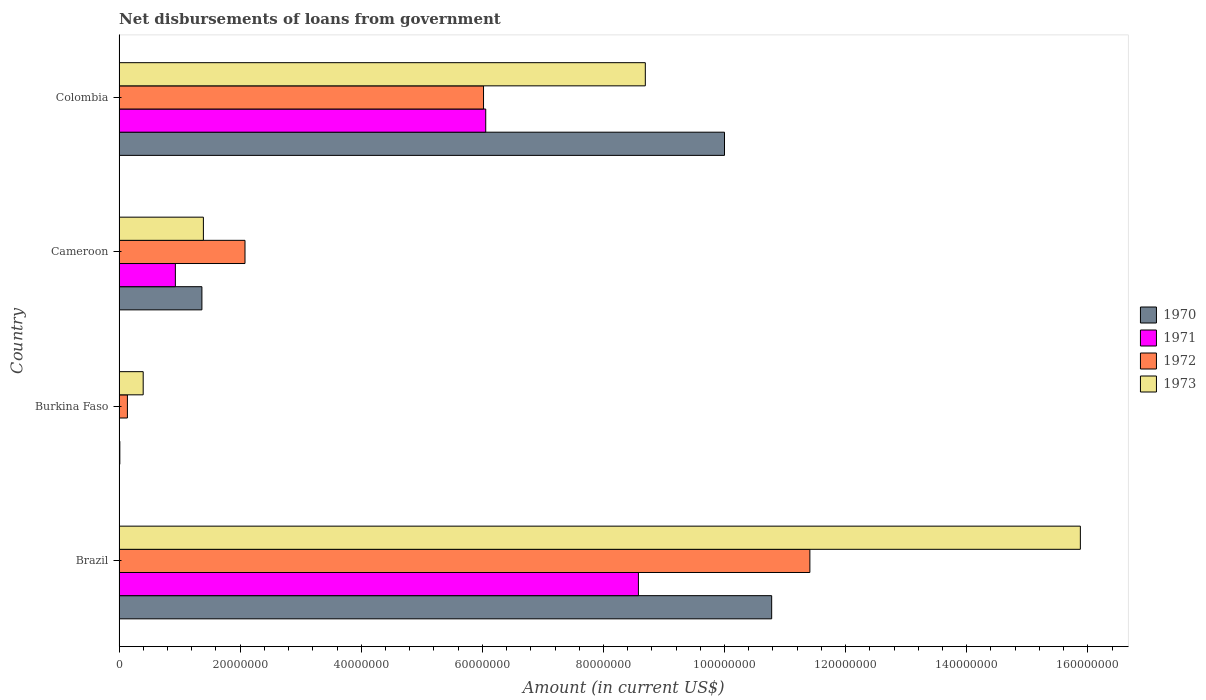How many different coloured bars are there?
Make the answer very short. 4. How many groups of bars are there?
Give a very brief answer. 4. Are the number of bars on each tick of the Y-axis equal?
Provide a succinct answer. No. How many bars are there on the 3rd tick from the top?
Offer a very short reply. 3. How many bars are there on the 4th tick from the bottom?
Your response must be concise. 4. What is the label of the 3rd group of bars from the top?
Your answer should be very brief. Burkina Faso. In how many cases, is the number of bars for a given country not equal to the number of legend labels?
Provide a succinct answer. 1. What is the amount of loan disbursed from government in 1973 in Colombia?
Keep it short and to the point. 8.69e+07. Across all countries, what is the maximum amount of loan disbursed from government in 1970?
Your answer should be very brief. 1.08e+08. Across all countries, what is the minimum amount of loan disbursed from government in 1972?
Give a very brief answer. 1.38e+06. What is the total amount of loan disbursed from government in 1971 in the graph?
Ensure brevity in your answer.  1.56e+08. What is the difference between the amount of loan disbursed from government in 1972 in Burkina Faso and that in Cameroon?
Keep it short and to the point. -1.94e+07. What is the difference between the amount of loan disbursed from government in 1972 in Burkina Faso and the amount of loan disbursed from government in 1971 in Cameroon?
Keep it short and to the point. -7.92e+06. What is the average amount of loan disbursed from government in 1973 per country?
Provide a short and direct response. 6.59e+07. What is the difference between the amount of loan disbursed from government in 1970 and amount of loan disbursed from government in 1972 in Brazil?
Keep it short and to the point. -6.31e+06. What is the ratio of the amount of loan disbursed from government in 1970 in Burkina Faso to that in Colombia?
Offer a terse response. 0. Is the amount of loan disbursed from government in 1972 in Brazil less than that in Burkina Faso?
Provide a succinct answer. No. Is the difference between the amount of loan disbursed from government in 1970 in Burkina Faso and Cameroon greater than the difference between the amount of loan disbursed from government in 1972 in Burkina Faso and Cameroon?
Provide a succinct answer. Yes. What is the difference between the highest and the second highest amount of loan disbursed from government in 1971?
Your response must be concise. 2.52e+07. What is the difference between the highest and the lowest amount of loan disbursed from government in 1973?
Ensure brevity in your answer.  1.55e+08. Is the sum of the amount of loan disbursed from government in 1972 in Cameroon and Colombia greater than the maximum amount of loan disbursed from government in 1971 across all countries?
Give a very brief answer. No. Is it the case that in every country, the sum of the amount of loan disbursed from government in 1971 and amount of loan disbursed from government in 1970 is greater than the amount of loan disbursed from government in 1972?
Offer a very short reply. No. Does the graph contain any zero values?
Your response must be concise. Yes. Does the graph contain grids?
Offer a terse response. No. Where does the legend appear in the graph?
Provide a short and direct response. Center right. How many legend labels are there?
Offer a very short reply. 4. How are the legend labels stacked?
Make the answer very short. Vertical. What is the title of the graph?
Provide a succinct answer. Net disbursements of loans from government. What is the label or title of the Y-axis?
Make the answer very short. Country. What is the Amount (in current US$) of 1970 in Brazil?
Keep it short and to the point. 1.08e+08. What is the Amount (in current US$) in 1971 in Brazil?
Give a very brief answer. 8.58e+07. What is the Amount (in current US$) in 1972 in Brazil?
Offer a terse response. 1.14e+08. What is the Amount (in current US$) in 1973 in Brazil?
Make the answer very short. 1.59e+08. What is the Amount (in current US$) in 1970 in Burkina Faso?
Offer a terse response. 1.29e+05. What is the Amount (in current US$) in 1971 in Burkina Faso?
Keep it short and to the point. 0. What is the Amount (in current US$) in 1972 in Burkina Faso?
Your answer should be very brief. 1.38e+06. What is the Amount (in current US$) of 1973 in Burkina Faso?
Ensure brevity in your answer.  3.98e+06. What is the Amount (in current US$) in 1970 in Cameroon?
Your answer should be compact. 1.37e+07. What is the Amount (in current US$) of 1971 in Cameroon?
Offer a terse response. 9.30e+06. What is the Amount (in current US$) of 1972 in Cameroon?
Offer a terse response. 2.08e+07. What is the Amount (in current US$) in 1973 in Cameroon?
Keep it short and to the point. 1.39e+07. What is the Amount (in current US$) in 1970 in Colombia?
Ensure brevity in your answer.  1.00e+08. What is the Amount (in current US$) in 1971 in Colombia?
Offer a very short reply. 6.06e+07. What is the Amount (in current US$) of 1972 in Colombia?
Your answer should be compact. 6.02e+07. What is the Amount (in current US$) in 1973 in Colombia?
Keep it short and to the point. 8.69e+07. Across all countries, what is the maximum Amount (in current US$) of 1970?
Your answer should be compact. 1.08e+08. Across all countries, what is the maximum Amount (in current US$) of 1971?
Give a very brief answer. 8.58e+07. Across all countries, what is the maximum Amount (in current US$) of 1972?
Keep it short and to the point. 1.14e+08. Across all countries, what is the maximum Amount (in current US$) in 1973?
Your response must be concise. 1.59e+08. Across all countries, what is the minimum Amount (in current US$) of 1970?
Offer a very short reply. 1.29e+05. Across all countries, what is the minimum Amount (in current US$) in 1972?
Keep it short and to the point. 1.38e+06. Across all countries, what is the minimum Amount (in current US$) in 1973?
Provide a short and direct response. 3.98e+06. What is the total Amount (in current US$) of 1970 in the graph?
Offer a very short reply. 2.22e+08. What is the total Amount (in current US$) in 1971 in the graph?
Provide a short and direct response. 1.56e+08. What is the total Amount (in current US$) in 1972 in the graph?
Keep it short and to the point. 1.96e+08. What is the total Amount (in current US$) of 1973 in the graph?
Offer a terse response. 2.64e+08. What is the difference between the Amount (in current US$) of 1970 in Brazil and that in Burkina Faso?
Your answer should be very brief. 1.08e+08. What is the difference between the Amount (in current US$) of 1972 in Brazil and that in Burkina Faso?
Make the answer very short. 1.13e+08. What is the difference between the Amount (in current US$) of 1973 in Brazil and that in Burkina Faso?
Provide a short and direct response. 1.55e+08. What is the difference between the Amount (in current US$) of 1970 in Brazil and that in Cameroon?
Provide a short and direct response. 9.41e+07. What is the difference between the Amount (in current US$) in 1971 in Brazil and that in Cameroon?
Keep it short and to the point. 7.65e+07. What is the difference between the Amount (in current US$) in 1972 in Brazil and that in Cameroon?
Provide a succinct answer. 9.33e+07. What is the difference between the Amount (in current US$) of 1973 in Brazil and that in Cameroon?
Offer a terse response. 1.45e+08. What is the difference between the Amount (in current US$) in 1970 in Brazil and that in Colombia?
Your answer should be compact. 7.79e+06. What is the difference between the Amount (in current US$) in 1971 in Brazil and that in Colombia?
Keep it short and to the point. 2.52e+07. What is the difference between the Amount (in current US$) in 1972 in Brazil and that in Colombia?
Offer a very short reply. 5.39e+07. What is the difference between the Amount (in current US$) of 1973 in Brazil and that in Colombia?
Offer a very short reply. 7.19e+07. What is the difference between the Amount (in current US$) in 1970 in Burkina Faso and that in Cameroon?
Offer a terse response. -1.36e+07. What is the difference between the Amount (in current US$) in 1972 in Burkina Faso and that in Cameroon?
Your response must be concise. -1.94e+07. What is the difference between the Amount (in current US$) in 1973 in Burkina Faso and that in Cameroon?
Provide a succinct answer. -9.94e+06. What is the difference between the Amount (in current US$) in 1970 in Burkina Faso and that in Colombia?
Your answer should be very brief. -9.99e+07. What is the difference between the Amount (in current US$) in 1972 in Burkina Faso and that in Colombia?
Ensure brevity in your answer.  -5.88e+07. What is the difference between the Amount (in current US$) in 1973 in Burkina Faso and that in Colombia?
Your response must be concise. -8.29e+07. What is the difference between the Amount (in current US$) of 1970 in Cameroon and that in Colombia?
Offer a terse response. -8.63e+07. What is the difference between the Amount (in current US$) in 1971 in Cameroon and that in Colombia?
Offer a terse response. -5.13e+07. What is the difference between the Amount (in current US$) in 1972 in Cameroon and that in Colombia?
Your answer should be very brief. -3.94e+07. What is the difference between the Amount (in current US$) in 1973 in Cameroon and that in Colombia?
Provide a succinct answer. -7.30e+07. What is the difference between the Amount (in current US$) of 1970 in Brazil and the Amount (in current US$) of 1972 in Burkina Faso?
Your answer should be very brief. 1.06e+08. What is the difference between the Amount (in current US$) of 1970 in Brazil and the Amount (in current US$) of 1973 in Burkina Faso?
Offer a very short reply. 1.04e+08. What is the difference between the Amount (in current US$) in 1971 in Brazil and the Amount (in current US$) in 1972 in Burkina Faso?
Give a very brief answer. 8.44e+07. What is the difference between the Amount (in current US$) in 1971 in Brazil and the Amount (in current US$) in 1973 in Burkina Faso?
Offer a very short reply. 8.18e+07. What is the difference between the Amount (in current US$) of 1972 in Brazil and the Amount (in current US$) of 1973 in Burkina Faso?
Make the answer very short. 1.10e+08. What is the difference between the Amount (in current US$) of 1970 in Brazil and the Amount (in current US$) of 1971 in Cameroon?
Offer a very short reply. 9.85e+07. What is the difference between the Amount (in current US$) in 1970 in Brazil and the Amount (in current US$) in 1972 in Cameroon?
Your response must be concise. 8.70e+07. What is the difference between the Amount (in current US$) of 1970 in Brazil and the Amount (in current US$) of 1973 in Cameroon?
Provide a succinct answer. 9.39e+07. What is the difference between the Amount (in current US$) of 1971 in Brazil and the Amount (in current US$) of 1972 in Cameroon?
Your response must be concise. 6.50e+07. What is the difference between the Amount (in current US$) in 1971 in Brazil and the Amount (in current US$) in 1973 in Cameroon?
Your answer should be compact. 7.18e+07. What is the difference between the Amount (in current US$) of 1972 in Brazil and the Amount (in current US$) of 1973 in Cameroon?
Provide a succinct answer. 1.00e+08. What is the difference between the Amount (in current US$) in 1970 in Brazil and the Amount (in current US$) in 1971 in Colombia?
Keep it short and to the point. 4.72e+07. What is the difference between the Amount (in current US$) of 1970 in Brazil and the Amount (in current US$) of 1972 in Colombia?
Make the answer very short. 4.76e+07. What is the difference between the Amount (in current US$) in 1970 in Brazil and the Amount (in current US$) in 1973 in Colombia?
Your answer should be very brief. 2.09e+07. What is the difference between the Amount (in current US$) of 1971 in Brazil and the Amount (in current US$) of 1972 in Colombia?
Your answer should be very brief. 2.56e+07. What is the difference between the Amount (in current US$) of 1971 in Brazil and the Amount (in current US$) of 1973 in Colombia?
Give a very brief answer. -1.14e+06. What is the difference between the Amount (in current US$) of 1972 in Brazil and the Amount (in current US$) of 1973 in Colombia?
Offer a very short reply. 2.72e+07. What is the difference between the Amount (in current US$) of 1970 in Burkina Faso and the Amount (in current US$) of 1971 in Cameroon?
Provide a short and direct response. -9.17e+06. What is the difference between the Amount (in current US$) in 1970 in Burkina Faso and the Amount (in current US$) in 1972 in Cameroon?
Keep it short and to the point. -2.07e+07. What is the difference between the Amount (in current US$) of 1970 in Burkina Faso and the Amount (in current US$) of 1973 in Cameroon?
Make the answer very short. -1.38e+07. What is the difference between the Amount (in current US$) in 1972 in Burkina Faso and the Amount (in current US$) in 1973 in Cameroon?
Provide a short and direct response. -1.25e+07. What is the difference between the Amount (in current US$) in 1970 in Burkina Faso and the Amount (in current US$) in 1971 in Colombia?
Keep it short and to the point. -6.04e+07. What is the difference between the Amount (in current US$) of 1970 in Burkina Faso and the Amount (in current US$) of 1972 in Colombia?
Offer a terse response. -6.01e+07. What is the difference between the Amount (in current US$) in 1970 in Burkina Faso and the Amount (in current US$) in 1973 in Colombia?
Make the answer very short. -8.68e+07. What is the difference between the Amount (in current US$) in 1972 in Burkina Faso and the Amount (in current US$) in 1973 in Colombia?
Your answer should be compact. -8.55e+07. What is the difference between the Amount (in current US$) of 1970 in Cameroon and the Amount (in current US$) of 1971 in Colombia?
Provide a succinct answer. -4.69e+07. What is the difference between the Amount (in current US$) in 1970 in Cameroon and the Amount (in current US$) in 1972 in Colombia?
Offer a terse response. -4.65e+07. What is the difference between the Amount (in current US$) of 1970 in Cameroon and the Amount (in current US$) of 1973 in Colombia?
Your answer should be very brief. -7.32e+07. What is the difference between the Amount (in current US$) of 1971 in Cameroon and the Amount (in current US$) of 1972 in Colombia?
Your response must be concise. -5.09e+07. What is the difference between the Amount (in current US$) in 1971 in Cameroon and the Amount (in current US$) in 1973 in Colombia?
Offer a terse response. -7.76e+07. What is the difference between the Amount (in current US$) of 1972 in Cameroon and the Amount (in current US$) of 1973 in Colombia?
Ensure brevity in your answer.  -6.61e+07. What is the average Amount (in current US$) in 1970 per country?
Ensure brevity in your answer.  5.54e+07. What is the average Amount (in current US$) of 1971 per country?
Provide a succinct answer. 3.89e+07. What is the average Amount (in current US$) in 1972 per country?
Your response must be concise. 4.91e+07. What is the average Amount (in current US$) in 1973 per country?
Offer a terse response. 6.59e+07. What is the difference between the Amount (in current US$) in 1970 and Amount (in current US$) in 1971 in Brazil?
Give a very brief answer. 2.20e+07. What is the difference between the Amount (in current US$) in 1970 and Amount (in current US$) in 1972 in Brazil?
Ensure brevity in your answer.  -6.31e+06. What is the difference between the Amount (in current US$) of 1970 and Amount (in current US$) of 1973 in Brazil?
Offer a very short reply. -5.10e+07. What is the difference between the Amount (in current US$) in 1971 and Amount (in current US$) in 1972 in Brazil?
Your response must be concise. -2.83e+07. What is the difference between the Amount (in current US$) in 1971 and Amount (in current US$) in 1973 in Brazil?
Make the answer very short. -7.30e+07. What is the difference between the Amount (in current US$) in 1972 and Amount (in current US$) in 1973 in Brazil?
Offer a terse response. -4.47e+07. What is the difference between the Amount (in current US$) in 1970 and Amount (in current US$) in 1972 in Burkina Faso?
Your answer should be very brief. -1.25e+06. What is the difference between the Amount (in current US$) in 1970 and Amount (in current US$) in 1973 in Burkina Faso?
Ensure brevity in your answer.  -3.86e+06. What is the difference between the Amount (in current US$) of 1972 and Amount (in current US$) of 1973 in Burkina Faso?
Your answer should be very brief. -2.60e+06. What is the difference between the Amount (in current US$) of 1970 and Amount (in current US$) of 1971 in Cameroon?
Keep it short and to the point. 4.38e+06. What is the difference between the Amount (in current US$) of 1970 and Amount (in current US$) of 1972 in Cameroon?
Ensure brevity in your answer.  -7.12e+06. What is the difference between the Amount (in current US$) of 1970 and Amount (in current US$) of 1973 in Cameroon?
Ensure brevity in your answer.  -2.45e+05. What is the difference between the Amount (in current US$) in 1971 and Amount (in current US$) in 1972 in Cameroon?
Give a very brief answer. -1.15e+07. What is the difference between the Amount (in current US$) of 1971 and Amount (in current US$) of 1973 in Cameroon?
Keep it short and to the point. -4.63e+06. What is the difference between the Amount (in current US$) of 1972 and Amount (in current US$) of 1973 in Cameroon?
Ensure brevity in your answer.  6.87e+06. What is the difference between the Amount (in current US$) in 1970 and Amount (in current US$) in 1971 in Colombia?
Make the answer very short. 3.94e+07. What is the difference between the Amount (in current US$) in 1970 and Amount (in current US$) in 1972 in Colombia?
Offer a terse response. 3.98e+07. What is the difference between the Amount (in current US$) of 1970 and Amount (in current US$) of 1973 in Colombia?
Offer a terse response. 1.31e+07. What is the difference between the Amount (in current US$) in 1971 and Amount (in current US$) in 1972 in Colombia?
Your answer should be very brief. 3.62e+05. What is the difference between the Amount (in current US$) in 1971 and Amount (in current US$) in 1973 in Colombia?
Provide a succinct answer. -2.64e+07. What is the difference between the Amount (in current US$) of 1972 and Amount (in current US$) of 1973 in Colombia?
Give a very brief answer. -2.67e+07. What is the ratio of the Amount (in current US$) of 1970 in Brazil to that in Burkina Faso?
Your response must be concise. 835.53. What is the ratio of the Amount (in current US$) in 1972 in Brazil to that in Burkina Faso?
Your answer should be compact. 82.68. What is the ratio of the Amount (in current US$) of 1973 in Brazil to that in Burkina Faso?
Your answer should be very brief. 39.84. What is the ratio of the Amount (in current US$) in 1970 in Brazil to that in Cameroon?
Your answer should be compact. 7.88. What is the ratio of the Amount (in current US$) in 1971 in Brazil to that in Cameroon?
Provide a short and direct response. 9.22. What is the ratio of the Amount (in current US$) in 1972 in Brazil to that in Cameroon?
Ensure brevity in your answer.  5.49. What is the ratio of the Amount (in current US$) in 1973 in Brazil to that in Cameroon?
Your response must be concise. 11.4. What is the ratio of the Amount (in current US$) of 1970 in Brazil to that in Colombia?
Your answer should be very brief. 1.08. What is the ratio of the Amount (in current US$) of 1971 in Brazil to that in Colombia?
Make the answer very short. 1.42. What is the ratio of the Amount (in current US$) in 1972 in Brazil to that in Colombia?
Provide a succinct answer. 1.9. What is the ratio of the Amount (in current US$) in 1973 in Brazil to that in Colombia?
Provide a succinct answer. 1.83. What is the ratio of the Amount (in current US$) of 1970 in Burkina Faso to that in Cameroon?
Your response must be concise. 0.01. What is the ratio of the Amount (in current US$) of 1972 in Burkina Faso to that in Cameroon?
Your response must be concise. 0.07. What is the ratio of the Amount (in current US$) in 1973 in Burkina Faso to that in Cameroon?
Make the answer very short. 0.29. What is the ratio of the Amount (in current US$) of 1970 in Burkina Faso to that in Colombia?
Offer a terse response. 0. What is the ratio of the Amount (in current US$) in 1972 in Burkina Faso to that in Colombia?
Offer a terse response. 0.02. What is the ratio of the Amount (in current US$) of 1973 in Burkina Faso to that in Colombia?
Offer a terse response. 0.05. What is the ratio of the Amount (in current US$) of 1970 in Cameroon to that in Colombia?
Keep it short and to the point. 0.14. What is the ratio of the Amount (in current US$) of 1971 in Cameroon to that in Colombia?
Your answer should be compact. 0.15. What is the ratio of the Amount (in current US$) of 1972 in Cameroon to that in Colombia?
Your answer should be compact. 0.35. What is the ratio of the Amount (in current US$) of 1973 in Cameroon to that in Colombia?
Provide a succinct answer. 0.16. What is the difference between the highest and the second highest Amount (in current US$) of 1970?
Your answer should be compact. 7.79e+06. What is the difference between the highest and the second highest Amount (in current US$) in 1971?
Your response must be concise. 2.52e+07. What is the difference between the highest and the second highest Amount (in current US$) of 1972?
Your answer should be compact. 5.39e+07. What is the difference between the highest and the second highest Amount (in current US$) in 1973?
Your response must be concise. 7.19e+07. What is the difference between the highest and the lowest Amount (in current US$) in 1970?
Your answer should be compact. 1.08e+08. What is the difference between the highest and the lowest Amount (in current US$) in 1971?
Give a very brief answer. 8.58e+07. What is the difference between the highest and the lowest Amount (in current US$) in 1972?
Your answer should be compact. 1.13e+08. What is the difference between the highest and the lowest Amount (in current US$) in 1973?
Make the answer very short. 1.55e+08. 